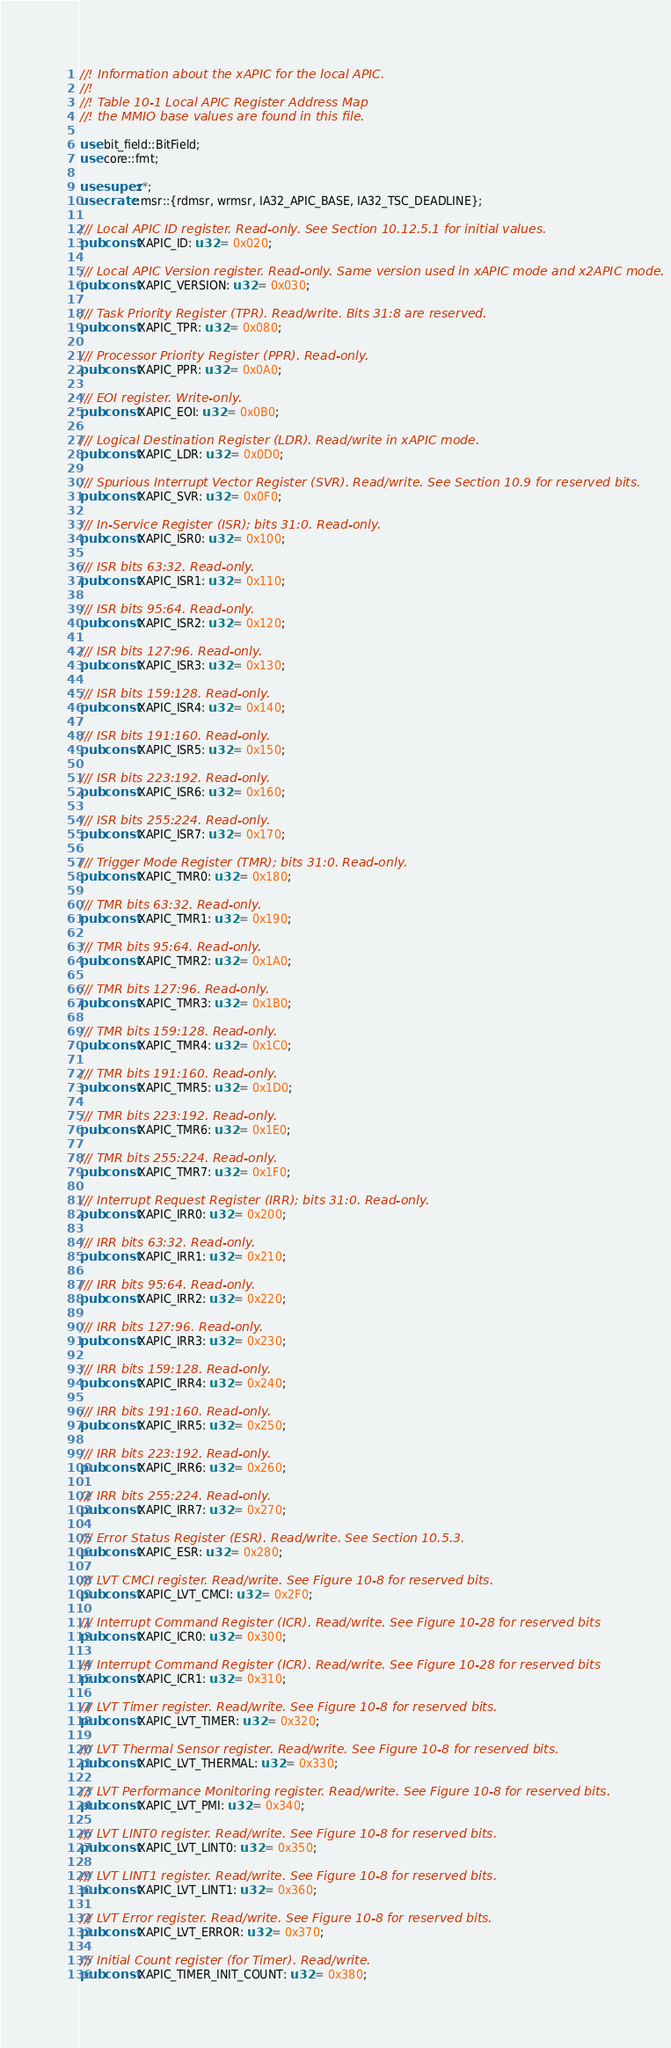<code> <loc_0><loc_0><loc_500><loc_500><_Rust_>//! Information about the xAPIC for the local APIC.
//!
//! Table 10-1 Local APIC Register Address Map
//! the MMIO base values are found in this file.

use bit_field::BitField;
use core::fmt;

use super::*;
use crate::msr::{rdmsr, wrmsr, IA32_APIC_BASE, IA32_TSC_DEADLINE};

/// Local APIC ID register. Read-only. See Section 10.12.5.1 for initial values.
pub const XAPIC_ID: u32 = 0x020;

/// Local APIC Version register. Read-only. Same version used in xAPIC mode and x2APIC mode.
pub const XAPIC_VERSION: u32 = 0x030;

/// Task Priority Register (TPR). Read/write. Bits 31:8 are reserved.
pub const XAPIC_TPR: u32 = 0x080;

/// Processor Priority Register (PPR). Read-only.
pub const XAPIC_PPR: u32 = 0x0A0;

/// EOI register. Write-only.
pub const XAPIC_EOI: u32 = 0x0B0;

/// Logical Destination Register (LDR). Read/write in xAPIC mode.
pub const XAPIC_LDR: u32 = 0x0D0;

/// Spurious Interrupt Vector Register (SVR). Read/write. See Section 10.9 for reserved bits.
pub const XAPIC_SVR: u32 = 0x0F0;

/// In-Service Register (ISR); bits 31:0. Read-only.
pub const XAPIC_ISR0: u32 = 0x100;

/// ISR bits 63:32. Read-only.
pub const XAPIC_ISR1: u32 = 0x110;

/// ISR bits 95:64. Read-only.
pub const XAPIC_ISR2: u32 = 0x120;

/// ISR bits 127:96. Read-only.
pub const XAPIC_ISR3: u32 = 0x130;

/// ISR bits 159:128. Read-only.
pub const XAPIC_ISR4: u32 = 0x140;

/// ISR bits 191:160. Read-only.
pub const XAPIC_ISR5: u32 = 0x150;

/// ISR bits 223:192. Read-only.
pub const XAPIC_ISR6: u32 = 0x160;

/// ISR bits 255:224. Read-only.
pub const XAPIC_ISR7: u32 = 0x170;

/// Trigger Mode Register (TMR); bits 31:0. Read-only.
pub const XAPIC_TMR0: u32 = 0x180;

/// TMR bits 63:32. Read-only.
pub const XAPIC_TMR1: u32 = 0x190;

/// TMR bits 95:64. Read-only.
pub const XAPIC_TMR2: u32 = 0x1A0;

/// TMR bits 127:96. Read-only.
pub const XAPIC_TMR3: u32 = 0x1B0;

/// TMR bits 159:128. Read-only.
pub const XAPIC_TMR4: u32 = 0x1C0;

/// TMR bits 191:160. Read-only.
pub const XAPIC_TMR5: u32 = 0x1D0;

/// TMR bits 223:192. Read-only.
pub const XAPIC_TMR6: u32 = 0x1E0;

/// TMR bits 255:224. Read-only.
pub const XAPIC_TMR7: u32 = 0x1F0;

/// Interrupt Request Register (IRR); bits 31:0. Read-only.
pub const XAPIC_IRR0: u32 = 0x200;

/// IRR bits 63:32. Read-only.
pub const XAPIC_IRR1: u32 = 0x210;

/// IRR bits 95:64. Read-only.
pub const XAPIC_IRR2: u32 = 0x220;

/// IRR bits 127:96. Read-only.
pub const XAPIC_IRR3: u32 = 0x230;

/// IRR bits 159:128. Read-only.
pub const XAPIC_IRR4: u32 = 0x240;

/// IRR bits 191:160. Read-only.
pub const XAPIC_IRR5: u32 = 0x250;

/// IRR bits 223:192. Read-only.
pub const XAPIC_IRR6: u32 = 0x260;

/// IRR bits 255:224. Read-only.
pub const XAPIC_IRR7: u32 = 0x270;

/// Error Status Register (ESR). Read/write. See Section 10.5.3.
pub const XAPIC_ESR: u32 = 0x280;

/// LVT CMCI register. Read/write. See Figure 10-8 for reserved bits.
pub const XAPIC_LVT_CMCI: u32 = 0x2F0;

/// Interrupt Command Register (ICR). Read/write. See Figure 10-28 for reserved bits
pub const XAPIC_ICR0: u32 = 0x300;

/// Interrupt Command Register (ICR). Read/write. See Figure 10-28 for reserved bits
pub const XAPIC_ICR1: u32 = 0x310;

/// LVT Timer register. Read/write. See Figure 10-8 for reserved bits.
pub const XAPIC_LVT_TIMER: u32 = 0x320;

/// LVT Thermal Sensor register. Read/write. See Figure 10-8 for reserved bits.
pub const XAPIC_LVT_THERMAL: u32 = 0x330;

/// LVT Performance Monitoring register. Read/write. See Figure 10-8 for reserved bits.
pub const XAPIC_LVT_PMI: u32 = 0x340;

/// LVT LINT0 register. Read/write. See Figure 10-8 for reserved bits.
pub const XAPIC_LVT_LINT0: u32 = 0x350;

/// LVT LINT1 register. Read/write. See Figure 10-8 for reserved bits.
pub const XAPIC_LVT_LINT1: u32 = 0x360;

/// LVT Error register. Read/write. See Figure 10-8 for reserved bits.
pub const XAPIC_LVT_ERROR: u32 = 0x370;

/// Initial Count register (for Timer). Read/write.
pub const XAPIC_TIMER_INIT_COUNT: u32 = 0x380;
</code> 